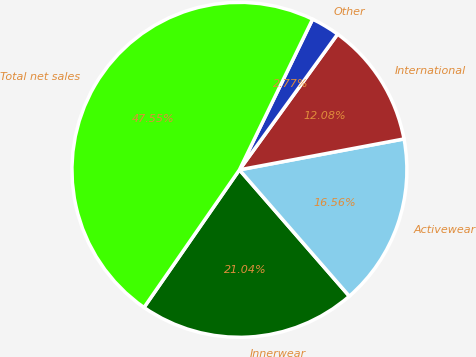Convert chart. <chart><loc_0><loc_0><loc_500><loc_500><pie_chart><fcel>Innerwear<fcel>Activewear<fcel>International<fcel>Other<fcel>Total net sales<nl><fcel>21.04%<fcel>16.56%<fcel>12.08%<fcel>2.77%<fcel>47.55%<nl></chart> 